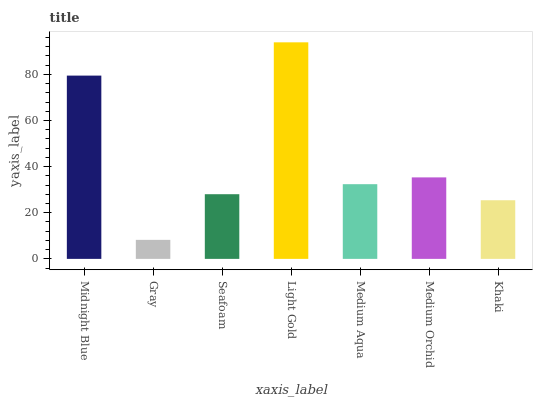Is Seafoam the minimum?
Answer yes or no. No. Is Seafoam the maximum?
Answer yes or no. No. Is Seafoam greater than Gray?
Answer yes or no. Yes. Is Gray less than Seafoam?
Answer yes or no. Yes. Is Gray greater than Seafoam?
Answer yes or no. No. Is Seafoam less than Gray?
Answer yes or no. No. Is Medium Aqua the high median?
Answer yes or no. Yes. Is Medium Aqua the low median?
Answer yes or no. Yes. Is Seafoam the high median?
Answer yes or no. No. Is Medium Orchid the low median?
Answer yes or no. No. 